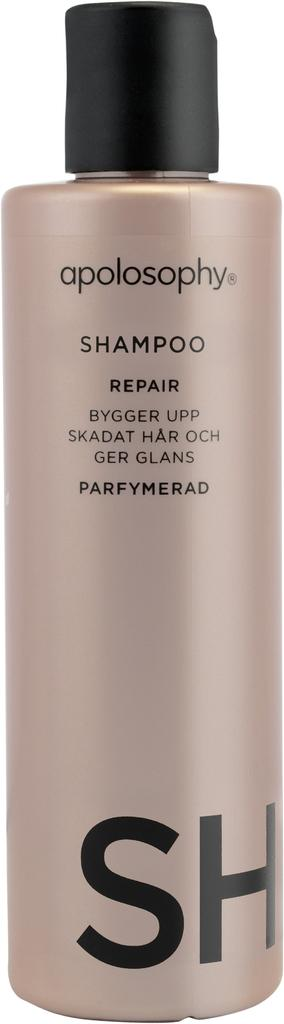<image>
Give a short and clear explanation of the subsequent image. Apolosophy repair shampoo is in a large pink bottle. 